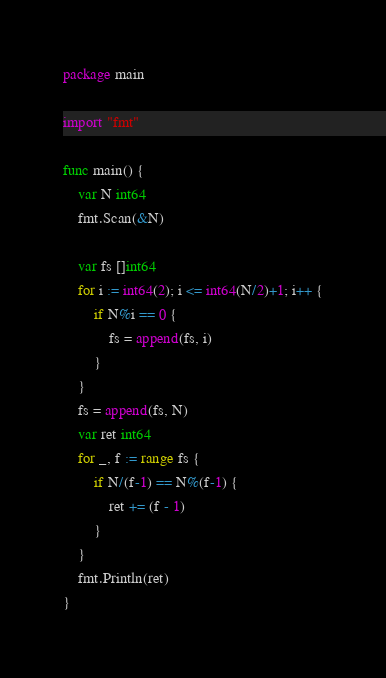Convert code to text. <code><loc_0><loc_0><loc_500><loc_500><_Go_>package main

import "fmt"

func main() {
	var N int64
	fmt.Scan(&N)

	var fs []int64
	for i := int64(2); i <= int64(N/2)+1; i++ {
		if N%i == 0 {
			fs = append(fs, i)
		}
	}
	fs = append(fs, N)
	var ret int64
	for _, f := range fs {
		if N/(f-1) == N%(f-1) {
			ret += (f - 1)
		}
	}
	fmt.Println(ret)
}
</code> 